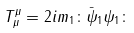<formula> <loc_0><loc_0><loc_500><loc_500>T _ { \mu } ^ { \mu } = 2 i m _ { 1 } \colon \bar { \psi } _ { 1 } \psi _ { 1 } \colon</formula> 